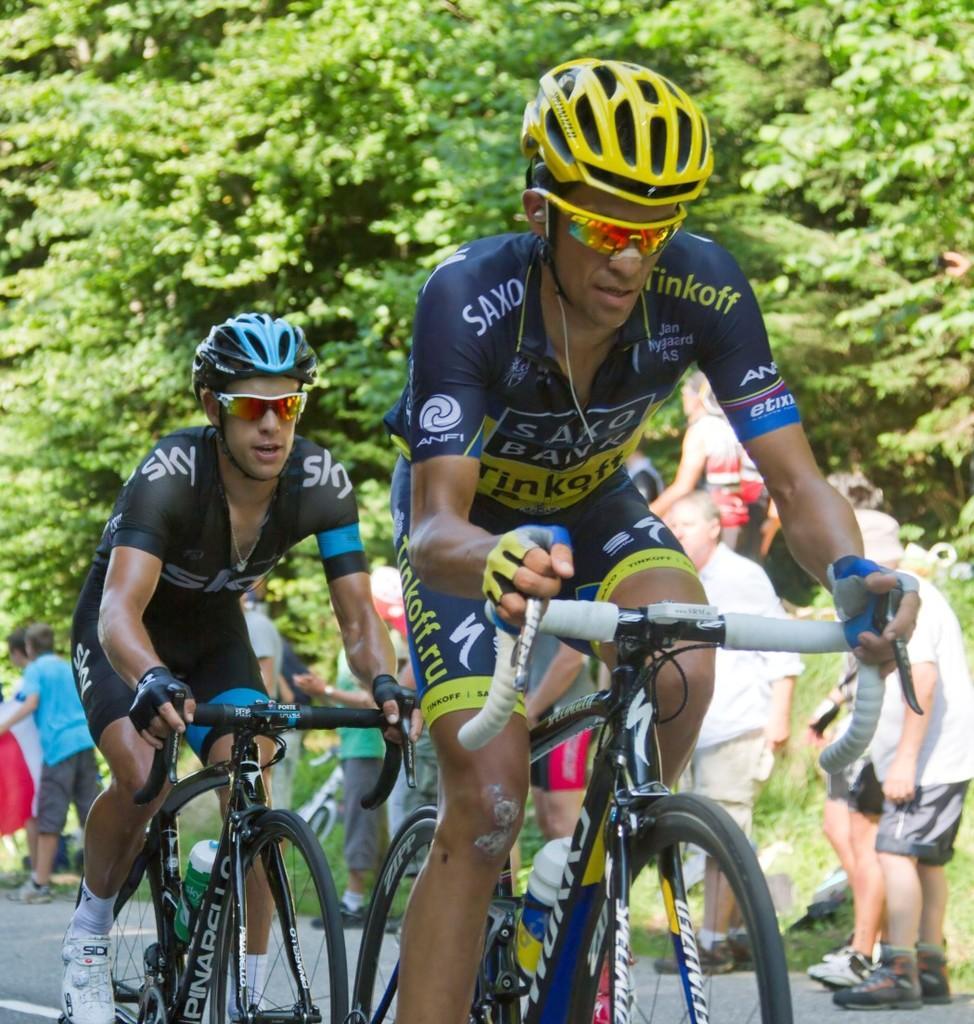In one or two sentences, can you explain what this image depicts? In this image, there are two persons riding bicycles with helmets and goggles. In the background, I can see a group of people standing and there are trees. 